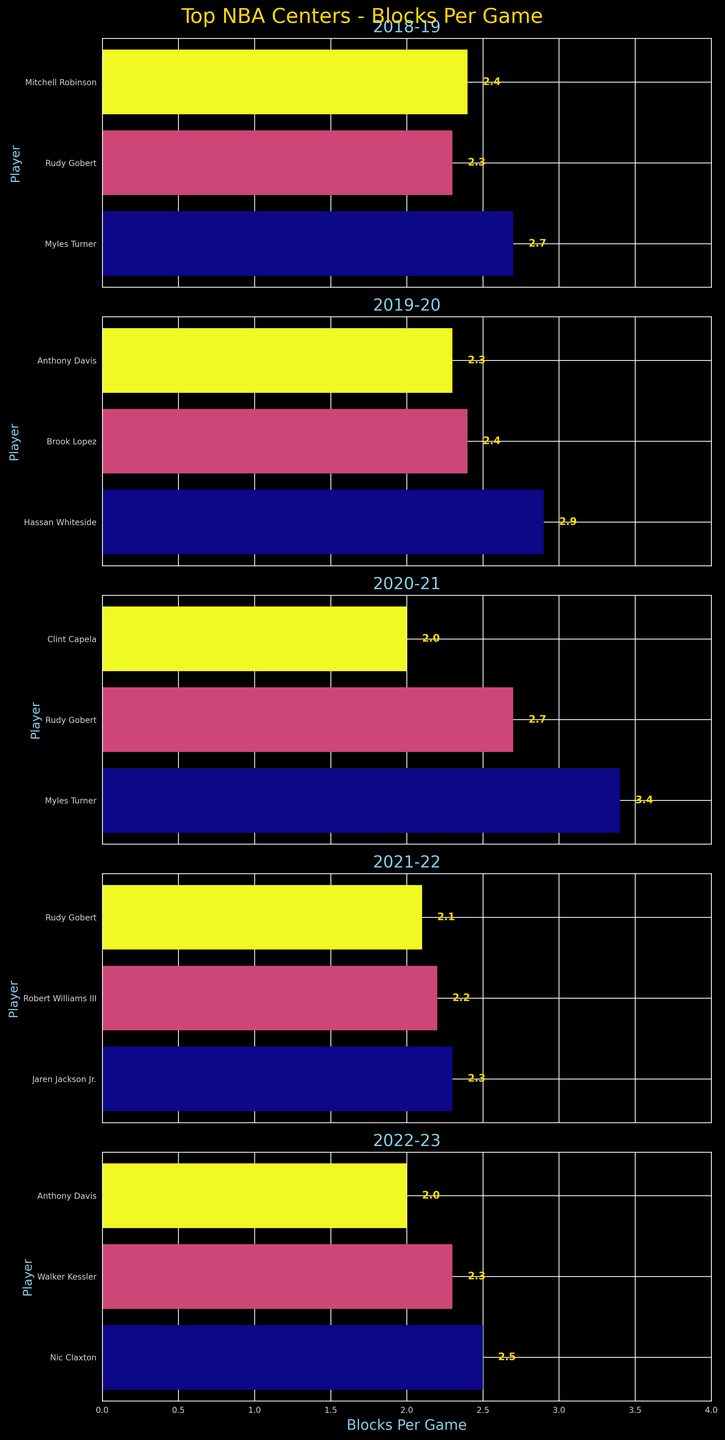What title is displayed above the vertical subplots? The figure's title is displayed prominently at the top, indicating the focus of the plots. It is "Top NBA Centers - Blocks Per Game".
Answer: Top NBA Centers - Blocks Per Game How many players are displayed for the 2019-20 season? To find this, locate the subplot labeled "2019-20". Count the number of bars representing players. There are 3 players: Hassan Whiteside, Brook Lopez, and Anthony Davis.
Answer: 3 Which player had the highest Blocks Per Game in the 2020-21 season, and what was the value? In the subplot titled "2020-21", observe the length of the horizontal bars. The longest bar belongs to Myles Turner with a value of 3.4.
Answer: Myles Turner, 3.4 Compare Rudy Gobert's performance in terms of Blocks Per Game across the given seasons. How has it changed? Locate the subplots for each season and find Rudy Gobert's bars. In 2018-19, he had 2.3 blocks per game, in 2019-20, 2.3 blocks per game, in 2020-21, 2.7 blocks per game, and in 2021-22, 2.1 blocks per game. His performance peaked in 2020-21.
Answer: Increased in 2020-21, then decreased What is the average Blocks Per Game for players in the 2021-22 season? Observe the 2021-22 subplot and sum the blocks per game values: 2.3 (Jaren Jackson Jr.) + 2.2 (Robert Williams III) + 2.1 (Rudy Gobert) = 6.6. There are 3 players, so the average is 6.6 / 3.
Answer: 2.2 Which team has the most players represented over the given seasons? Scan all subplots and count the frequencies of players from each team. Utah Jazz has 4 instances: Rudy Gobert (3 times) and Walker Kessler (once).
Answer: Utah Jazz Who had more Blocks Per Game in the 2018-19 season: Myles Turner or Mitchell Robinson? In the 2018-19 subplot, compare the lengths of bars for Myles Turner and Mitchell Robinson. Myles Turner had 2.7, while Mitchell Robinson had 2.4 blocks per game.
Answer: Myles Turner What is the range of Blocks Per Game among players in the 2022-23 season? Identify the highest and lowest values in the 2022-23 subplot. The highest is Nic Claxton with 2.5 and the lowest is Anthony Davis with 2.0 blocks per game. Subtracting 2.0 from 2.5 gives the range.
Answer: 0.5 How did Anthony Davis's Blocks Per Game change between the 2019-20 and 2022-23 seasons? Compare his values in the respective subplots. In the 2019-20 season, he recorded 2.3 blocks per game, and in the 2022-23 season, he recorded 2.0 blocks per game. Determine the difference.
Answer: Decreased by 0.3 